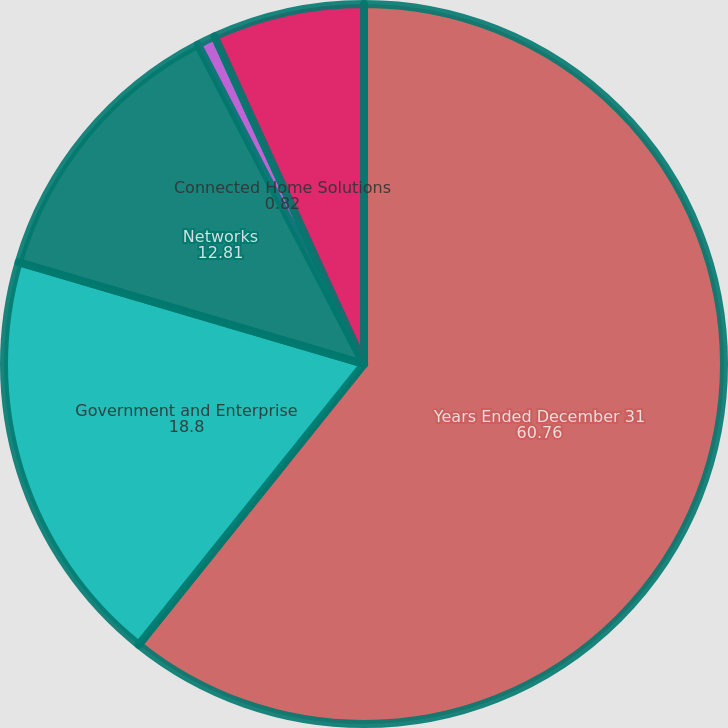Convert chart to OTSL. <chart><loc_0><loc_0><loc_500><loc_500><pie_chart><fcel>Years Ended December 31<fcel>Government and Enterprise<fcel>Networks<fcel>Connected Home Solutions<fcel>Other and Eliminations<nl><fcel>60.76%<fcel>18.8%<fcel>12.81%<fcel>0.82%<fcel>6.81%<nl></chart> 